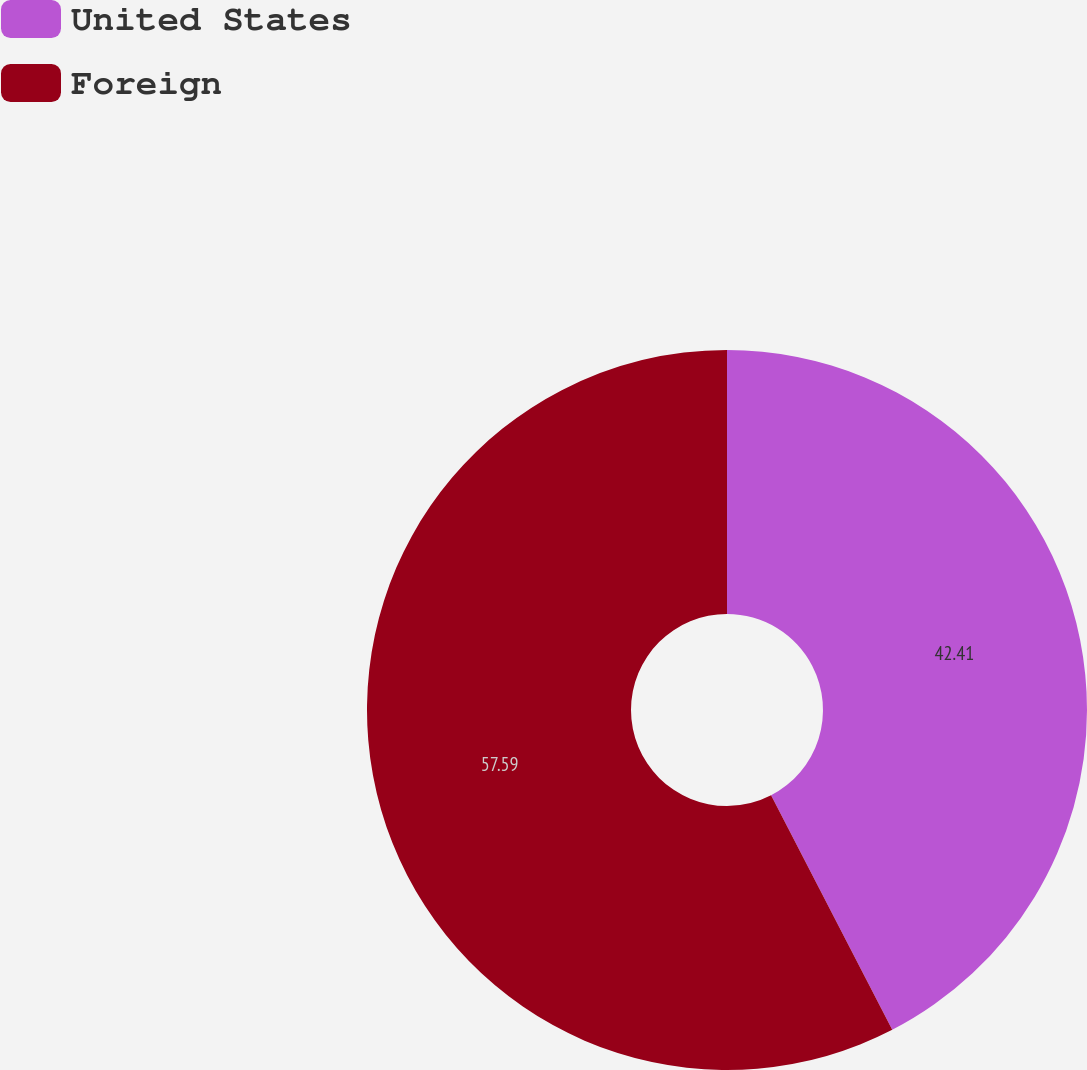<chart> <loc_0><loc_0><loc_500><loc_500><pie_chart><fcel>United States<fcel>Foreign<nl><fcel>42.41%<fcel>57.59%<nl></chart> 